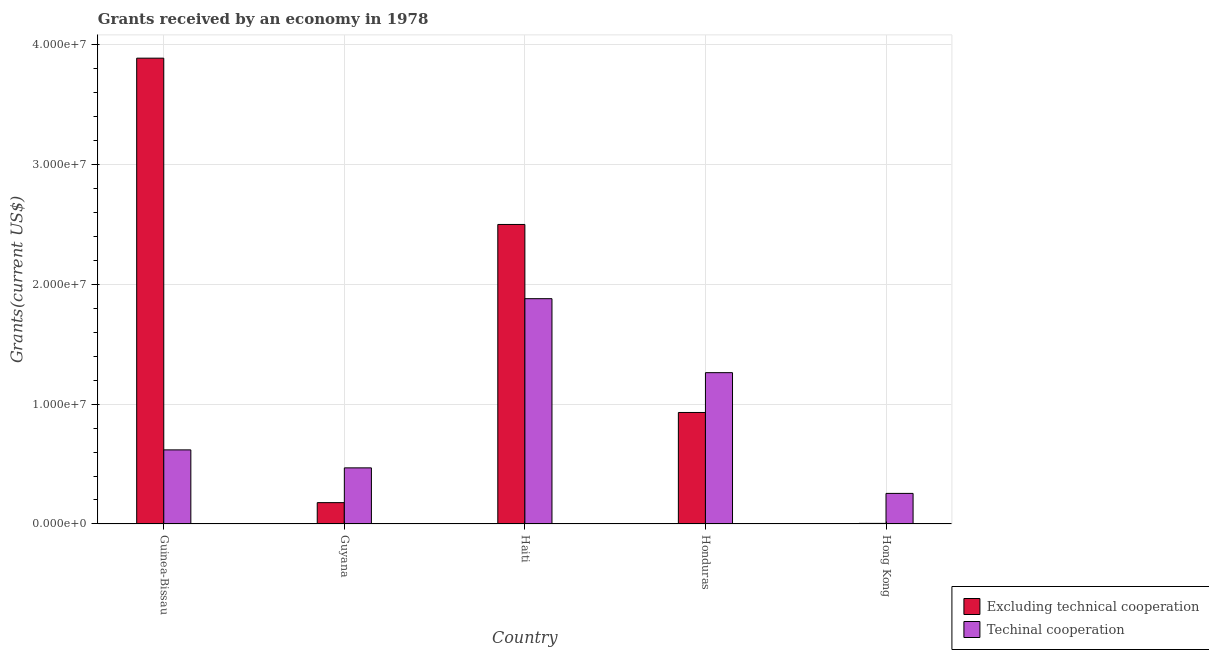How many different coloured bars are there?
Your answer should be compact. 2. Are the number of bars per tick equal to the number of legend labels?
Offer a very short reply. Yes. Are the number of bars on each tick of the X-axis equal?
Your answer should be very brief. Yes. How many bars are there on the 4th tick from the right?
Your response must be concise. 2. What is the label of the 2nd group of bars from the left?
Make the answer very short. Guyana. What is the amount of grants received(excluding technical cooperation) in Hong Kong?
Make the answer very short. 5.00e+04. Across all countries, what is the maximum amount of grants received(including technical cooperation)?
Your answer should be very brief. 1.88e+07. Across all countries, what is the minimum amount of grants received(including technical cooperation)?
Offer a very short reply. 2.55e+06. In which country was the amount of grants received(excluding technical cooperation) maximum?
Your response must be concise. Guinea-Bissau. In which country was the amount of grants received(excluding technical cooperation) minimum?
Give a very brief answer. Hong Kong. What is the total amount of grants received(excluding technical cooperation) in the graph?
Your response must be concise. 7.50e+07. What is the difference between the amount of grants received(including technical cooperation) in Haiti and that in Honduras?
Provide a succinct answer. 6.17e+06. What is the difference between the amount of grants received(including technical cooperation) in Haiti and the amount of grants received(excluding technical cooperation) in Honduras?
Keep it short and to the point. 9.49e+06. What is the average amount of grants received(including technical cooperation) per country?
Your response must be concise. 8.96e+06. What is the difference between the amount of grants received(including technical cooperation) and amount of grants received(excluding technical cooperation) in Haiti?
Provide a short and direct response. -6.19e+06. In how many countries, is the amount of grants received(including technical cooperation) greater than 24000000 US$?
Your answer should be compact. 0. What is the ratio of the amount of grants received(excluding technical cooperation) in Guinea-Bissau to that in Hong Kong?
Your answer should be compact. 777. Is the amount of grants received(including technical cooperation) in Guyana less than that in Haiti?
Keep it short and to the point. Yes. Is the difference between the amount of grants received(excluding technical cooperation) in Guinea-Bissau and Guyana greater than the difference between the amount of grants received(including technical cooperation) in Guinea-Bissau and Guyana?
Offer a very short reply. Yes. What is the difference between the highest and the second highest amount of grants received(including technical cooperation)?
Your answer should be compact. 6.17e+06. What is the difference between the highest and the lowest amount of grants received(excluding technical cooperation)?
Your answer should be very brief. 3.88e+07. What does the 2nd bar from the left in Honduras represents?
Ensure brevity in your answer.  Techinal cooperation. What does the 1st bar from the right in Hong Kong represents?
Offer a very short reply. Techinal cooperation. How many bars are there?
Offer a terse response. 10. Are all the bars in the graph horizontal?
Keep it short and to the point. No. How many countries are there in the graph?
Give a very brief answer. 5. Does the graph contain any zero values?
Provide a succinct answer. No. How many legend labels are there?
Keep it short and to the point. 2. What is the title of the graph?
Make the answer very short. Grants received by an economy in 1978. Does "Arms exports" appear as one of the legend labels in the graph?
Offer a very short reply. No. What is the label or title of the X-axis?
Provide a short and direct response. Country. What is the label or title of the Y-axis?
Provide a short and direct response. Grants(current US$). What is the Grants(current US$) of Excluding technical cooperation in Guinea-Bissau?
Give a very brief answer. 3.88e+07. What is the Grants(current US$) of Techinal cooperation in Guinea-Bissau?
Provide a succinct answer. 6.18e+06. What is the Grants(current US$) in Excluding technical cooperation in Guyana?
Give a very brief answer. 1.78e+06. What is the Grants(current US$) of Techinal cooperation in Guyana?
Your answer should be compact. 4.68e+06. What is the Grants(current US$) in Excluding technical cooperation in Haiti?
Provide a succinct answer. 2.50e+07. What is the Grants(current US$) in Techinal cooperation in Haiti?
Give a very brief answer. 1.88e+07. What is the Grants(current US$) in Excluding technical cooperation in Honduras?
Give a very brief answer. 9.30e+06. What is the Grants(current US$) of Techinal cooperation in Honduras?
Your answer should be compact. 1.26e+07. What is the Grants(current US$) in Excluding technical cooperation in Hong Kong?
Your answer should be very brief. 5.00e+04. What is the Grants(current US$) in Techinal cooperation in Hong Kong?
Give a very brief answer. 2.55e+06. Across all countries, what is the maximum Grants(current US$) in Excluding technical cooperation?
Offer a terse response. 3.88e+07. Across all countries, what is the maximum Grants(current US$) in Techinal cooperation?
Your answer should be very brief. 1.88e+07. Across all countries, what is the minimum Grants(current US$) of Excluding technical cooperation?
Your answer should be compact. 5.00e+04. Across all countries, what is the minimum Grants(current US$) of Techinal cooperation?
Make the answer very short. 2.55e+06. What is the total Grants(current US$) in Excluding technical cooperation in the graph?
Provide a short and direct response. 7.50e+07. What is the total Grants(current US$) in Techinal cooperation in the graph?
Your response must be concise. 4.48e+07. What is the difference between the Grants(current US$) in Excluding technical cooperation in Guinea-Bissau and that in Guyana?
Provide a short and direct response. 3.71e+07. What is the difference between the Grants(current US$) in Techinal cooperation in Guinea-Bissau and that in Guyana?
Keep it short and to the point. 1.50e+06. What is the difference between the Grants(current US$) of Excluding technical cooperation in Guinea-Bissau and that in Haiti?
Make the answer very short. 1.39e+07. What is the difference between the Grants(current US$) in Techinal cooperation in Guinea-Bissau and that in Haiti?
Ensure brevity in your answer.  -1.26e+07. What is the difference between the Grants(current US$) of Excluding technical cooperation in Guinea-Bissau and that in Honduras?
Your answer should be very brief. 2.96e+07. What is the difference between the Grants(current US$) of Techinal cooperation in Guinea-Bissau and that in Honduras?
Your response must be concise. -6.44e+06. What is the difference between the Grants(current US$) in Excluding technical cooperation in Guinea-Bissau and that in Hong Kong?
Provide a succinct answer. 3.88e+07. What is the difference between the Grants(current US$) of Techinal cooperation in Guinea-Bissau and that in Hong Kong?
Provide a succinct answer. 3.63e+06. What is the difference between the Grants(current US$) of Excluding technical cooperation in Guyana and that in Haiti?
Ensure brevity in your answer.  -2.32e+07. What is the difference between the Grants(current US$) in Techinal cooperation in Guyana and that in Haiti?
Offer a very short reply. -1.41e+07. What is the difference between the Grants(current US$) of Excluding technical cooperation in Guyana and that in Honduras?
Offer a terse response. -7.52e+06. What is the difference between the Grants(current US$) of Techinal cooperation in Guyana and that in Honduras?
Your response must be concise. -7.94e+06. What is the difference between the Grants(current US$) of Excluding technical cooperation in Guyana and that in Hong Kong?
Offer a very short reply. 1.73e+06. What is the difference between the Grants(current US$) of Techinal cooperation in Guyana and that in Hong Kong?
Offer a very short reply. 2.13e+06. What is the difference between the Grants(current US$) of Excluding technical cooperation in Haiti and that in Honduras?
Offer a very short reply. 1.57e+07. What is the difference between the Grants(current US$) in Techinal cooperation in Haiti and that in Honduras?
Give a very brief answer. 6.17e+06. What is the difference between the Grants(current US$) in Excluding technical cooperation in Haiti and that in Hong Kong?
Keep it short and to the point. 2.49e+07. What is the difference between the Grants(current US$) of Techinal cooperation in Haiti and that in Hong Kong?
Offer a terse response. 1.62e+07. What is the difference between the Grants(current US$) in Excluding technical cooperation in Honduras and that in Hong Kong?
Your answer should be compact. 9.25e+06. What is the difference between the Grants(current US$) in Techinal cooperation in Honduras and that in Hong Kong?
Ensure brevity in your answer.  1.01e+07. What is the difference between the Grants(current US$) in Excluding technical cooperation in Guinea-Bissau and the Grants(current US$) in Techinal cooperation in Guyana?
Your response must be concise. 3.42e+07. What is the difference between the Grants(current US$) in Excluding technical cooperation in Guinea-Bissau and the Grants(current US$) in Techinal cooperation in Haiti?
Provide a succinct answer. 2.01e+07. What is the difference between the Grants(current US$) in Excluding technical cooperation in Guinea-Bissau and the Grants(current US$) in Techinal cooperation in Honduras?
Ensure brevity in your answer.  2.62e+07. What is the difference between the Grants(current US$) in Excluding technical cooperation in Guinea-Bissau and the Grants(current US$) in Techinal cooperation in Hong Kong?
Provide a short and direct response. 3.63e+07. What is the difference between the Grants(current US$) of Excluding technical cooperation in Guyana and the Grants(current US$) of Techinal cooperation in Haiti?
Offer a very short reply. -1.70e+07. What is the difference between the Grants(current US$) of Excluding technical cooperation in Guyana and the Grants(current US$) of Techinal cooperation in Honduras?
Give a very brief answer. -1.08e+07. What is the difference between the Grants(current US$) of Excluding technical cooperation in Guyana and the Grants(current US$) of Techinal cooperation in Hong Kong?
Offer a very short reply. -7.70e+05. What is the difference between the Grants(current US$) of Excluding technical cooperation in Haiti and the Grants(current US$) of Techinal cooperation in Honduras?
Offer a very short reply. 1.24e+07. What is the difference between the Grants(current US$) of Excluding technical cooperation in Haiti and the Grants(current US$) of Techinal cooperation in Hong Kong?
Your answer should be compact. 2.24e+07. What is the difference between the Grants(current US$) of Excluding technical cooperation in Honduras and the Grants(current US$) of Techinal cooperation in Hong Kong?
Keep it short and to the point. 6.75e+06. What is the average Grants(current US$) of Excluding technical cooperation per country?
Your response must be concise. 1.50e+07. What is the average Grants(current US$) in Techinal cooperation per country?
Your response must be concise. 8.96e+06. What is the difference between the Grants(current US$) in Excluding technical cooperation and Grants(current US$) in Techinal cooperation in Guinea-Bissau?
Offer a very short reply. 3.27e+07. What is the difference between the Grants(current US$) in Excluding technical cooperation and Grants(current US$) in Techinal cooperation in Guyana?
Offer a very short reply. -2.90e+06. What is the difference between the Grants(current US$) in Excluding technical cooperation and Grants(current US$) in Techinal cooperation in Haiti?
Your answer should be compact. 6.19e+06. What is the difference between the Grants(current US$) in Excluding technical cooperation and Grants(current US$) in Techinal cooperation in Honduras?
Keep it short and to the point. -3.32e+06. What is the difference between the Grants(current US$) of Excluding technical cooperation and Grants(current US$) of Techinal cooperation in Hong Kong?
Offer a very short reply. -2.50e+06. What is the ratio of the Grants(current US$) in Excluding technical cooperation in Guinea-Bissau to that in Guyana?
Your answer should be compact. 21.83. What is the ratio of the Grants(current US$) of Techinal cooperation in Guinea-Bissau to that in Guyana?
Your answer should be compact. 1.32. What is the ratio of the Grants(current US$) in Excluding technical cooperation in Guinea-Bissau to that in Haiti?
Provide a succinct answer. 1.56. What is the ratio of the Grants(current US$) of Techinal cooperation in Guinea-Bissau to that in Haiti?
Offer a terse response. 0.33. What is the ratio of the Grants(current US$) of Excluding technical cooperation in Guinea-Bissau to that in Honduras?
Provide a short and direct response. 4.18. What is the ratio of the Grants(current US$) of Techinal cooperation in Guinea-Bissau to that in Honduras?
Provide a short and direct response. 0.49. What is the ratio of the Grants(current US$) in Excluding technical cooperation in Guinea-Bissau to that in Hong Kong?
Make the answer very short. 777. What is the ratio of the Grants(current US$) in Techinal cooperation in Guinea-Bissau to that in Hong Kong?
Give a very brief answer. 2.42. What is the ratio of the Grants(current US$) of Excluding technical cooperation in Guyana to that in Haiti?
Offer a terse response. 0.07. What is the ratio of the Grants(current US$) of Techinal cooperation in Guyana to that in Haiti?
Give a very brief answer. 0.25. What is the ratio of the Grants(current US$) in Excluding technical cooperation in Guyana to that in Honduras?
Keep it short and to the point. 0.19. What is the ratio of the Grants(current US$) in Techinal cooperation in Guyana to that in Honduras?
Provide a short and direct response. 0.37. What is the ratio of the Grants(current US$) of Excluding technical cooperation in Guyana to that in Hong Kong?
Provide a short and direct response. 35.6. What is the ratio of the Grants(current US$) in Techinal cooperation in Guyana to that in Hong Kong?
Keep it short and to the point. 1.84. What is the ratio of the Grants(current US$) in Excluding technical cooperation in Haiti to that in Honduras?
Offer a terse response. 2.69. What is the ratio of the Grants(current US$) of Techinal cooperation in Haiti to that in Honduras?
Ensure brevity in your answer.  1.49. What is the ratio of the Grants(current US$) in Excluding technical cooperation in Haiti to that in Hong Kong?
Your response must be concise. 499.6. What is the ratio of the Grants(current US$) of Techinal cooperation in Haiti to that in Hong Kong?
Offer a very short reply. 7.37. What is the ratio of the Grants(current US$) of Excluding technical cooperation in Honduras to that in Hong Kong?
Give a very brief answer. 186. What is the ratio of the Grants(current US$) in Techinal cooperation in Honduras to that in Hong Kong?
Ensure brevity in your answer.  4.95. What is the difference between the highest and the second highest Grants(current US$) of Excluding technical cooperation?
Your answer should be very brief. 1.39e+07. What is the difference between the highest and the second highest Grants(current US$) in Techinal cooperation?
Your answer should be very brief. 6.17e+06. What is the difference between the highest and the lowest Grants(current US$) of Excluding technical cooperation?
Give a very brief answer. 3.88e+07. What is the difference between the highest and the lowest Grants(current US$) in Techinal cooperation?
Your answer should be very brief. 1.62e+07. 